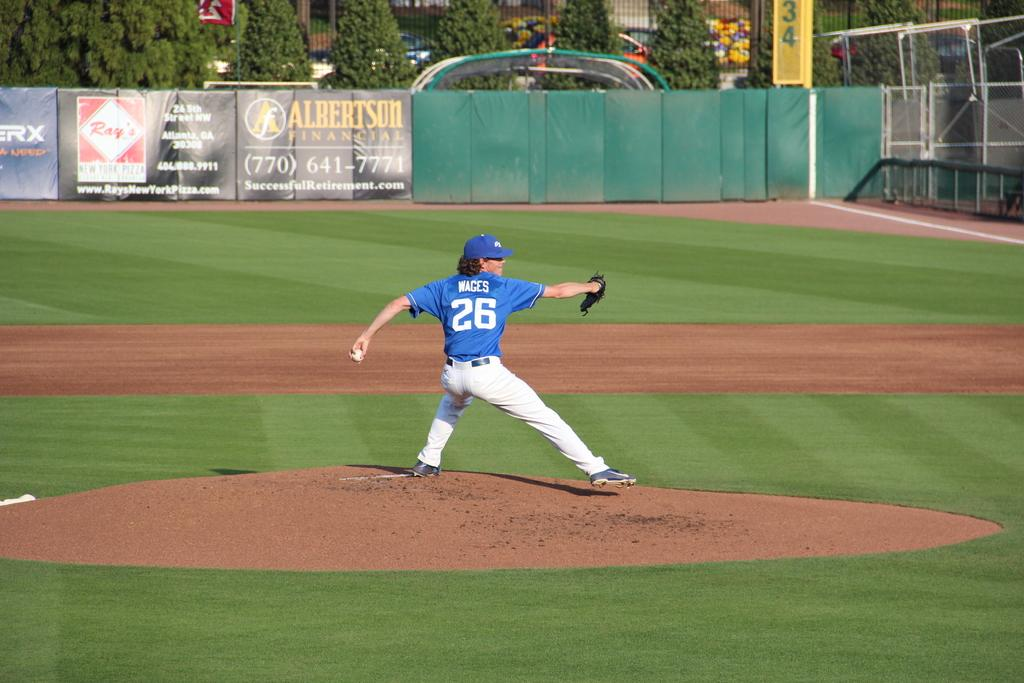<image>
Provide a brief description of the given image. Baseball pitcher wages who is number 26 in mid pitch. 